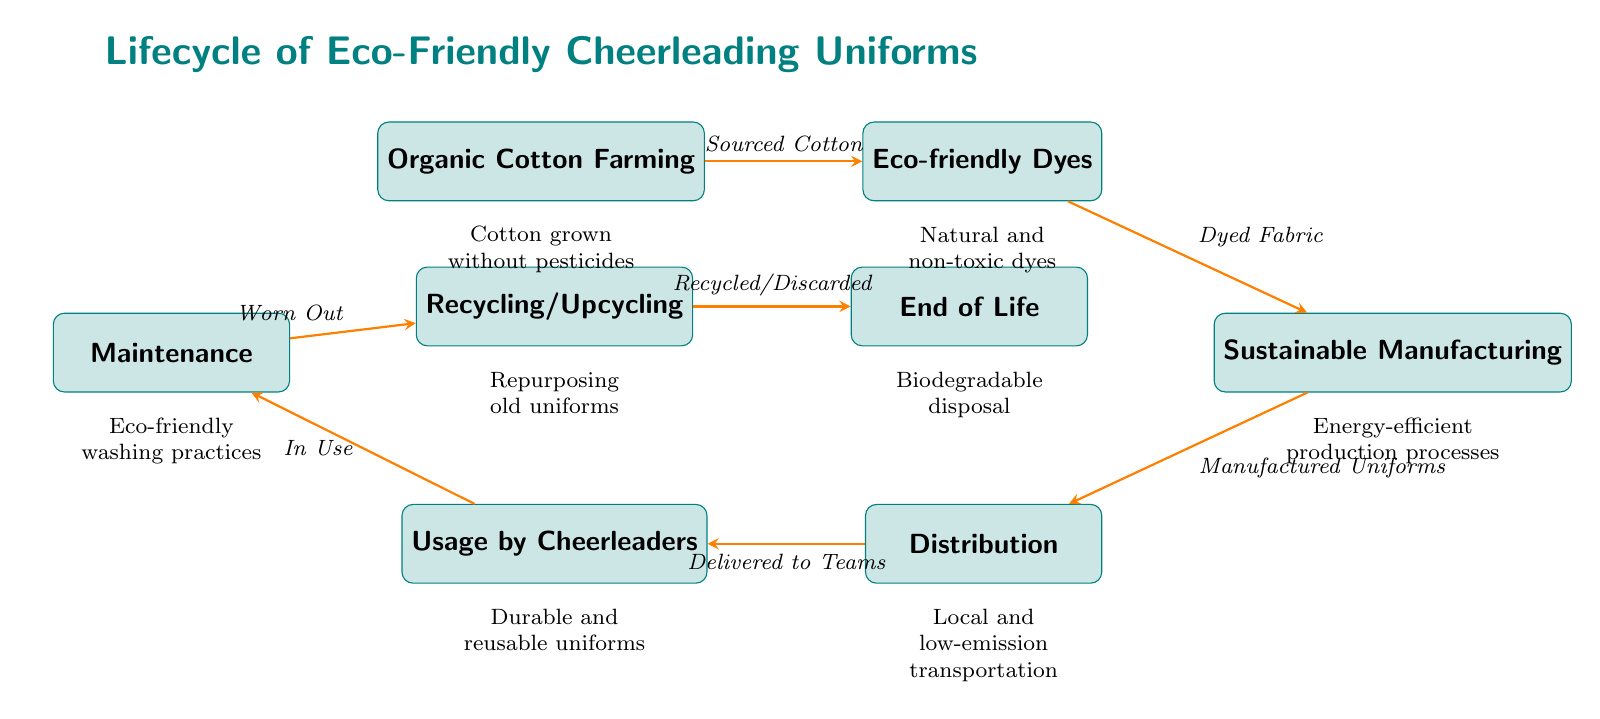What is the first step in the lifecycle? The diagram shows that "Organic Cotton Farming" is the first process in the lifecycle of eco-friendly cheerleading uniforms.
Answer: Organic Cotton Farming How many processes are listed in the diagram? By counting each of the unique process nodes in the diagram, we find there are eight distinct processes from start to end.
Answer: 8 What type of cotton is used in this lifecycle? The diagram specifies that the lifecycle begins with "Cotton grown without pesticides," indicating the use of organic cotton.
Answer: Organic cotton What happens to uniforms after they are worn out? According to the diagram, once the uniforms are "Worn Out," they proceed to "Recycling/Upcycling."
Answer: Recycling/Upcycling What step follows "Sustainable Manufacturing"? The flow direction shows that after "Sustainable Manufacturing," the next step is "Distribution."
Answer: Distribution What kind of transportation is utilized in the distribution process? The diagram indicates that the transportation used during distribution is described as "Local and low-emission transportation."
Answer: Local and low-emission transportation How are uniforms maintained during use? The diagram reflects that during the usage phase, uniforms are subject to "Eco-friendly washing practices."
Answer: Eco-friendly washing practices What phase comes after "End of Life"? The diagram does not specify a phase after "End of Life," suggesting this is the final stage in the lifecycle process.
Answer: None Which dyeing method is used for the fabrics? The process named "Eco-friendly Dyes" indicates that natural and non-toxic dyes are used, as stated in the diagram.
Answer: Natural and non-toxic dyes 